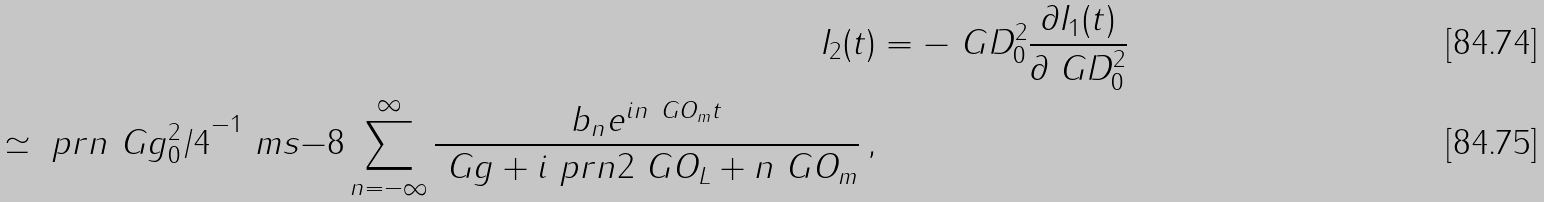Convert formula to latex. <formula><loc_0><loc_0><loc_500><loc_500>I _ { 2 } ( t ) & = - \ G D _ { 0 } ^ { 2 } \frac { \partial I _ { 1 } ( t ) } { \partial \ G D _ { 0 } ^ { 2 } } \\ \simeq \ p r n { \ G g _ { 0 } ^ { 2 } / 4 } ^ { - 1 } \ m s { - 8 } \sum _ { n = - \infty } ^ { \infty } \frac { b _ { n } e ^ { i n \ G O _ { m } t } } { \ G g + i \ p r n { 2 \ G O _ { L } + n \ G O _ { m } } } \, ,</formula> 